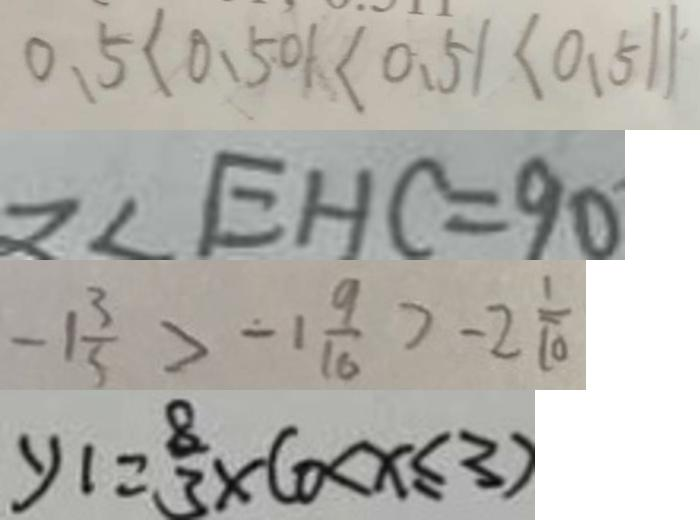Convert formula to latex. <formula><loc_0><loc_0><loc_500><loc_500>0 . 5 < 0 . 5 0 1 < 0 . 5 1 < 0 . 5 1 1 
 = \angle E H C = 9 0 
 - 1 \frac { 3 } { 5 } > - 1 \frac { 9 } { 1 6 } > - 2 \frac { 1 } { 1 0 } 
 y _ { 1 } = \frac { 8 } { 3 } \times ( 0 < x \leq 3 )</formula> 